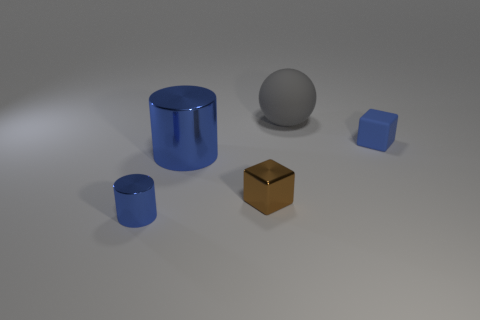Add 2 small brown objects. How many objects exist? 7 Subtract all spheres. How many objects are left? 4 Add 2 large blue metallic things. How many large blue metallic things are left? 3 Add 2 cubes. How many cubes exist? 4 Subtract 0 green cylinders. How many objects are left? 5 Subtract all tiny red spheres. Subtract all big things. How many objects are left? 3 